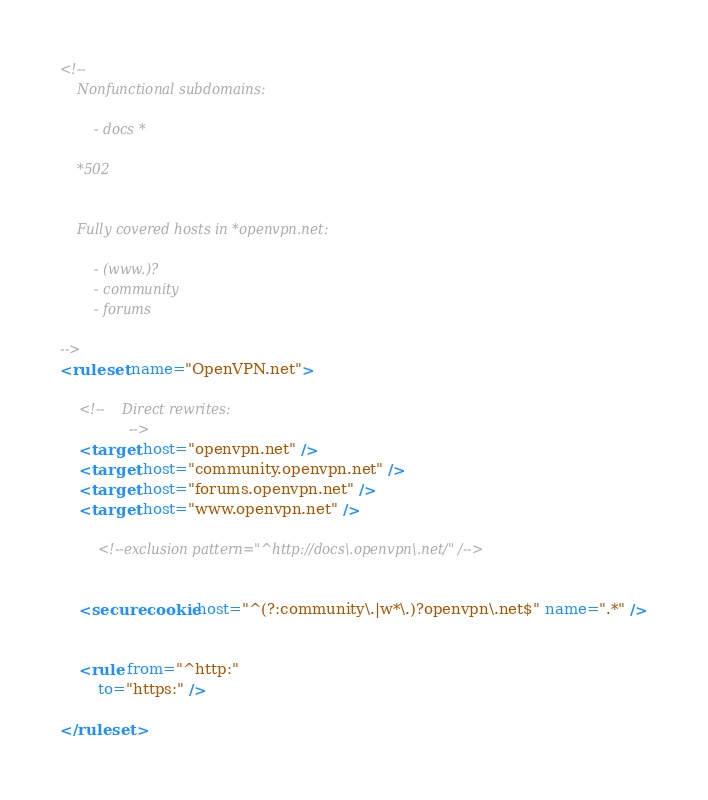Convert code to text. <code><loc_0><loc_0><loc_500><loc_500><_XML_><!--
	Nonfunctional subdomains:

		- docs *

	*502


	Fully covered hosts in *openvpn.net:

		- (www.)?
		- community
		- forums

-->
<ruleset name="OpenVPN.net">

	<!--	Direct rewrites:
				-->
	<target host="openvpn.net" />
	<target host="community.openvpn.net" />
	<target host="forums.openvpn.net" />
	<target host="www.openvpn.net" />

		<!--exclusion pattern="^http://docs\.openvpn\.net/" /-->


	<securecookie host="^(?:community\.|w*\.)?openvpn\.net$" name=".*" />


	<rule from="^http:"
		to="https:" />

</ruleset>
</code> 